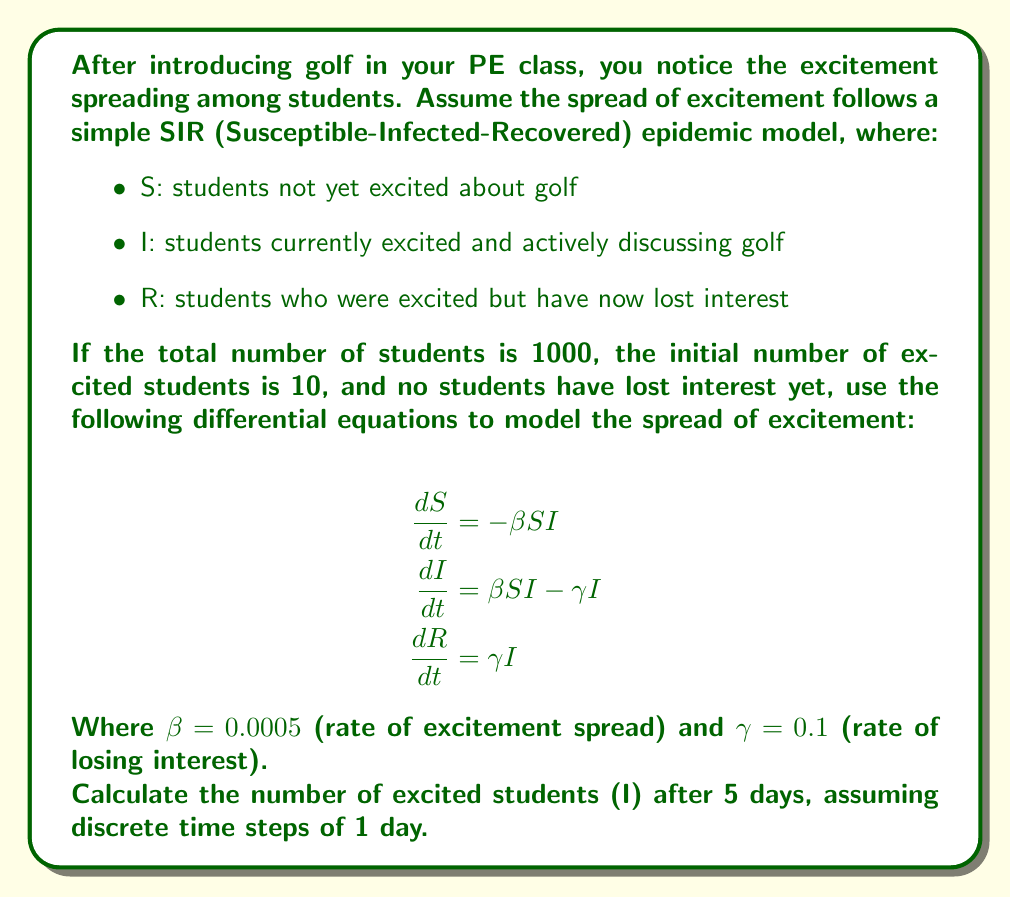Can you solve this math problem? To solve this problem, we'll use the Euler method to approximate the solution of the differential equations over discrete time steps. We'll calculate the values of S, I, and R for each day.

Initial conditions:
S(0) = 990 (1000 total - 10 initially excited)
I(0) = 10
R(0) = 0

For each day t, we'll use the following equations:

$$S(t+1) = S(t) - \beta S(t)I(t)$$
$$I(t+1) = I(t) + \beta S(t)I(t) - \gamma I(t)$$
$$R(t+1) = R(t) + \gamma I(t)$$

Let's calculate for each day:

Day 1:
$$S(1) = 990 - 0.0005 \times 990 \times 10 = 985.05$$
$$I(1) = 10 + 0.0005 \times 990 \times 10 - 0.1 \times 10 = 14.45$$
$$R(1) = 0 + 0.1 \times 10 = 1$$

Day 2:
$$S(2) = 985.05 - 0.0005 \times 985.05 \times 14.45 = 977.93$$
$$I(2) = 14.45 + 0.0005 \times 985.05 \times 14.45 - 0.1 \times 14.45 = 20.49$$
$$R(2) = 1 + 0.1 \times 14.45 = 2.45$$

Day 3:
$$S(3) = 977.93 - 0.0005 \times 977.93 \times 20.49 = 967.91$$
$$I(3) = 20.49 + 0.0005 \times 977.93 \times 20.49 - 0.1 \times 20.49 = 28.57$$
$$R(3) = 2.45 + 0.1 \times 20.49 = 4.50$$

Day 4:
$$S(4) = 967.91 - 0.0005 \times 967.91 \times 28.57 = 954.11$$
$$I(4) = 28.57 + 0.0005 \times 967.91 \times 28.57 - 0.1 \times 28.57 = 39.18$$
$$R(4) = 4.50 + 0.1 \times 28.57 = 7.36$$

Day 5:
$$S(5) = 954.11 - 0.0005 \times 954.11 \times 39.18 = 935.46$$
$$I(5) = 39.18 + 0.0005 \times 954.11 \times 39.18 - 0.1 \times 39.18 = 52.65$$
$$R(5) = 7.36 + 0.1 \times 39.18 = 11.28$$

Therefore, after 5 days, the number of excited students (I) is approximately 52.65.
Answer: 52.65 students (rounded to two decimal places) 